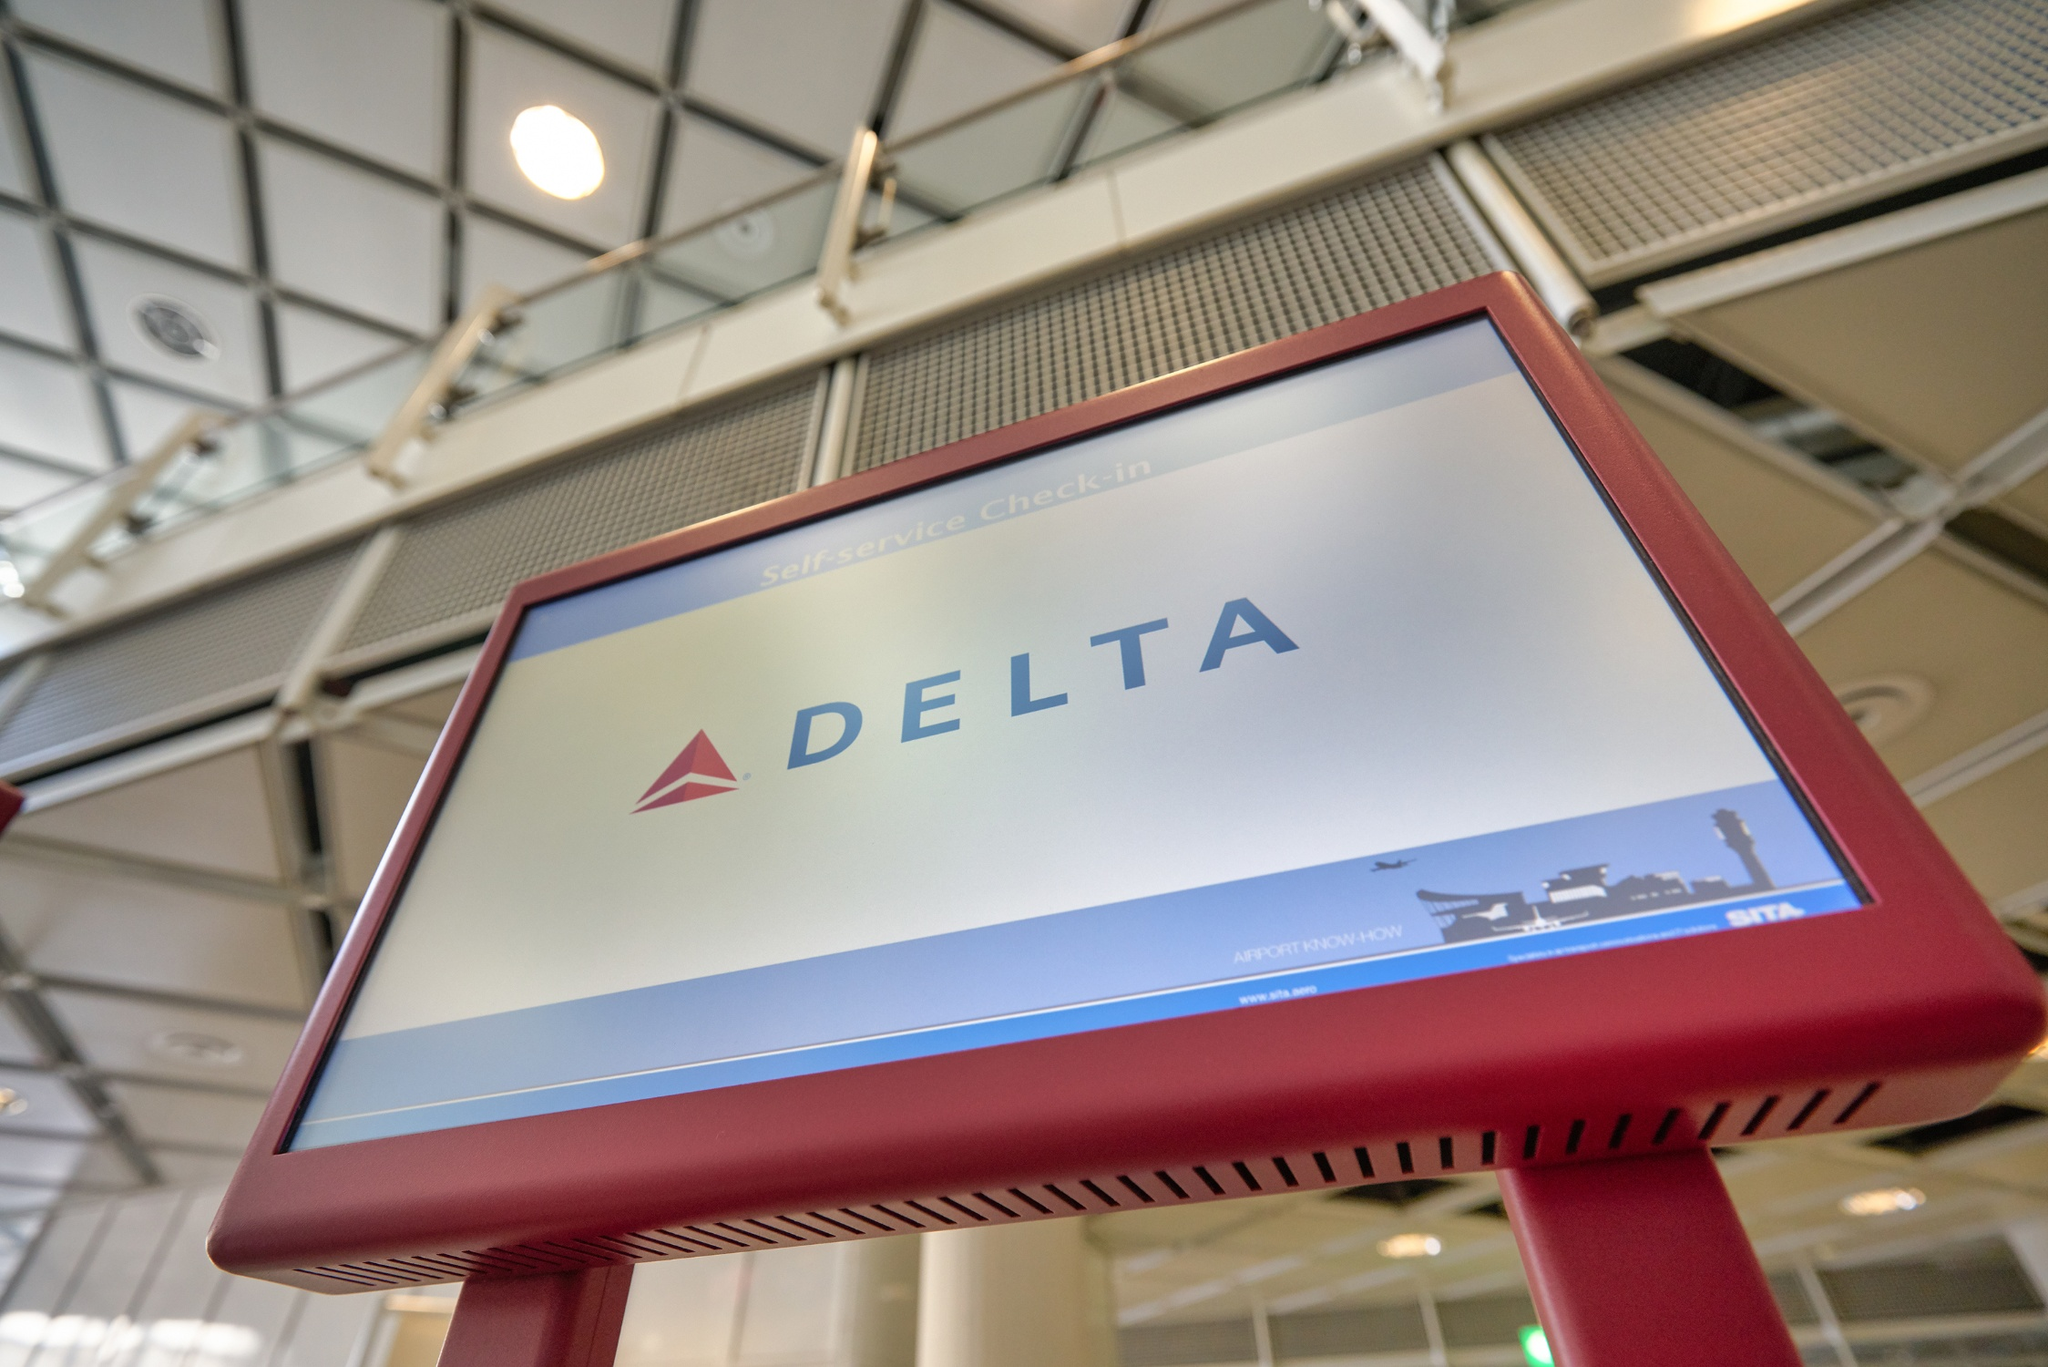A creative question: If this Delta kiosk were enchanted and became a wizard’s portal on special occasions, how might it transform and what would travelers experience? Should this Delta kiosk become an enchanted wizard’s portal, on special occasions it would elegantly transform, glowing with a soft, mystical light. The screen might ripple like water, revealing ancient runes that shimmer and dance. As travelers approach, they would hear a melodic hum, signaling that magic is at play. When they touch the screen, instead of a typical check-in process, they would be transported through a swirling vortex of shimmering lights and stars, emerging in a distant land or another time. Perhaps they find themselves in a bustling medieval market, the rolling hills of a mystical realm, or even on the deck of a starship heading to uncharted galaxies. This transformation would offer more than a journey; it would be an adventure, an escape from the mundane into the extraordinary. 